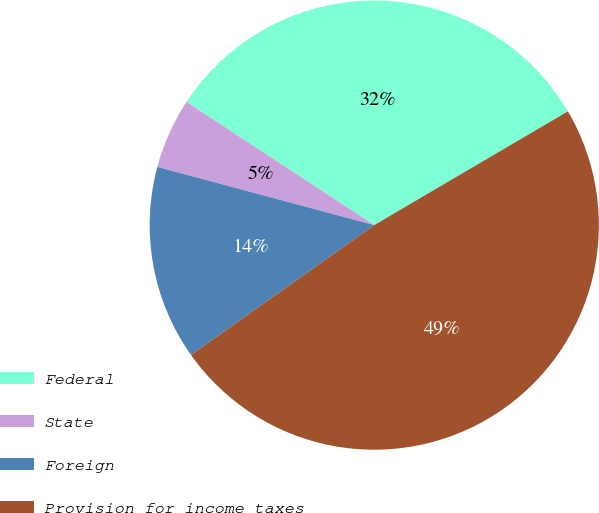<chart> <loc_0><loc_0><loc_500><loc_500><pie_chart><fcel>Federal<fcel>State<fcel>Foreign<fcel>Provision for income taxes<nl><fcel>32.3%<fcel>5.07%<fcel>13.98%<fcel>48.64%<nl></chart> 